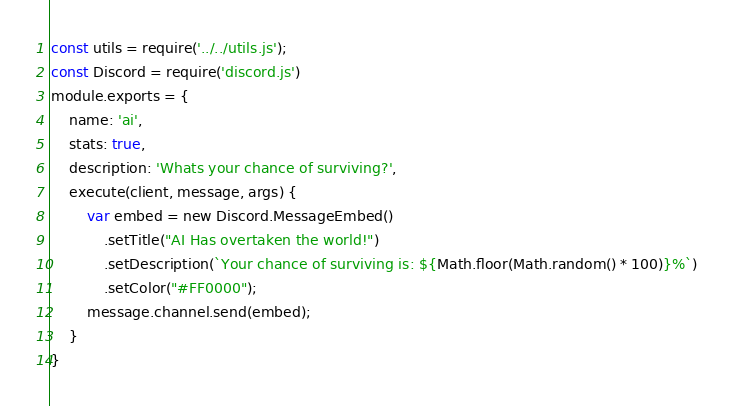<code> <loc_0><loc_0><loc_500><loc_500><_JavaScript_>const utils = require('../../utils.js');
const Discord = require('discord.js')
module.exports = {
    name: 'ai',
    stats: true,
    description: 'Whats your chance of surviving?',
    execute(client, message, args) {
        var embed = new Discord.MessageEmbed()
            .setTitle("AI Has overtaken the world!")
            .setDescription(`Your chance of surviving is: ${Math.floor(Math.random() * 100)}%`)
            .setColor("#FF0000");
        message.channel.send(embed);
    }
}</code> 